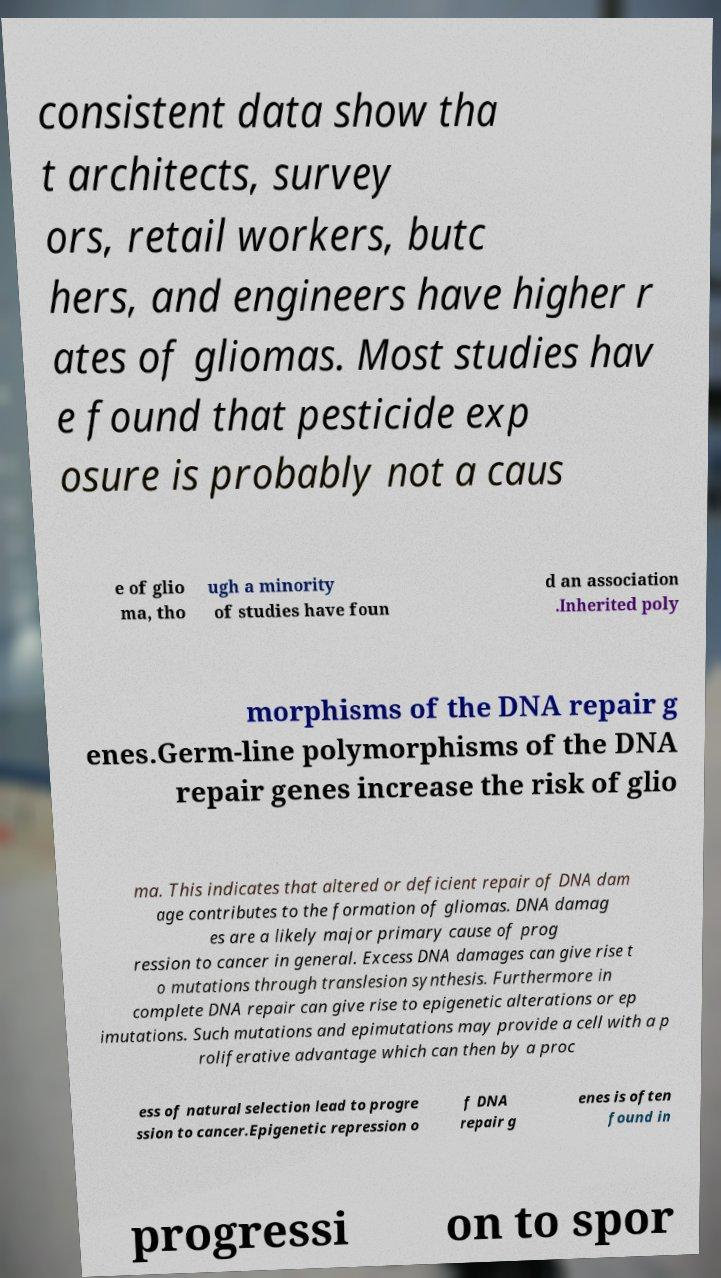What messages or text are displayed in this image? I need them in a readable, typed format. consistent data show tha t architects, survey ors, retail workers, butc hers, and engineers have higher r ates of gliomas. Most studies hav e found that pesticide exp osure is probably not a caus e of glio ma, tho ugh a minority of studies have foun d an association .Inherited poly morphisms of the DNA repair g enes.Germ-line polymorphisms of the DNA repair genes increase the risk of glio ma. This indicates that altered or deficient repair of DNA dam age contributes to the formation of gliomas. DNA damag es are a likely major primary cause of prog ression to cancer in general. Excess DNA damages can give rise t o mutations through translesion synthesis. Furthermore in complete DNA repair can give rise to epigenetic alterations or ep imutations. Such mutations and epimutations may provide a cell with a p roliferative advantage which can then by a proc ess of natural selection lead to progre ssion to cancer.Epigenetic repression o f DNA repair g enes is often found in progressi on to spor 